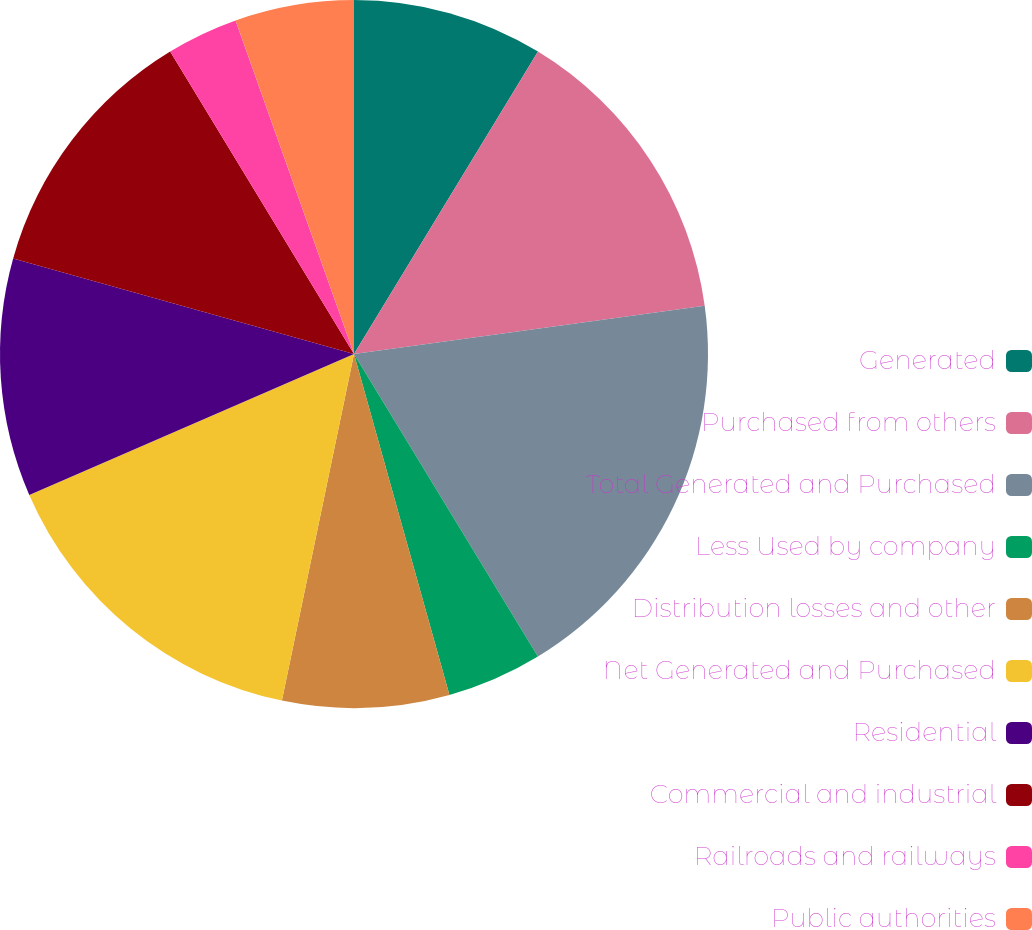Convert chart. <chart><loc_0><loc_0><loc_500><loc_500><pie_chart><fcel>Generated<fcel>Purchased from others<fcel>Total Generated and Purchased<fcel>Less Used by company<fcel>Distribution losses and other<fcel>Net Generated and Purchased<fcel>Residential<fcel>Commercial and industrial<fcel>Railroads and railways<fcel>Public authorities<nl><fcel>8.7%<fcel>14.13%<fcel>18.48%<fcel>4.35%<fcel>7.61%<fcel>15.22%<fcel>10.87%<fcel>11.96%<fcel>3.26%<fcel>5.43%<nl></chart> 